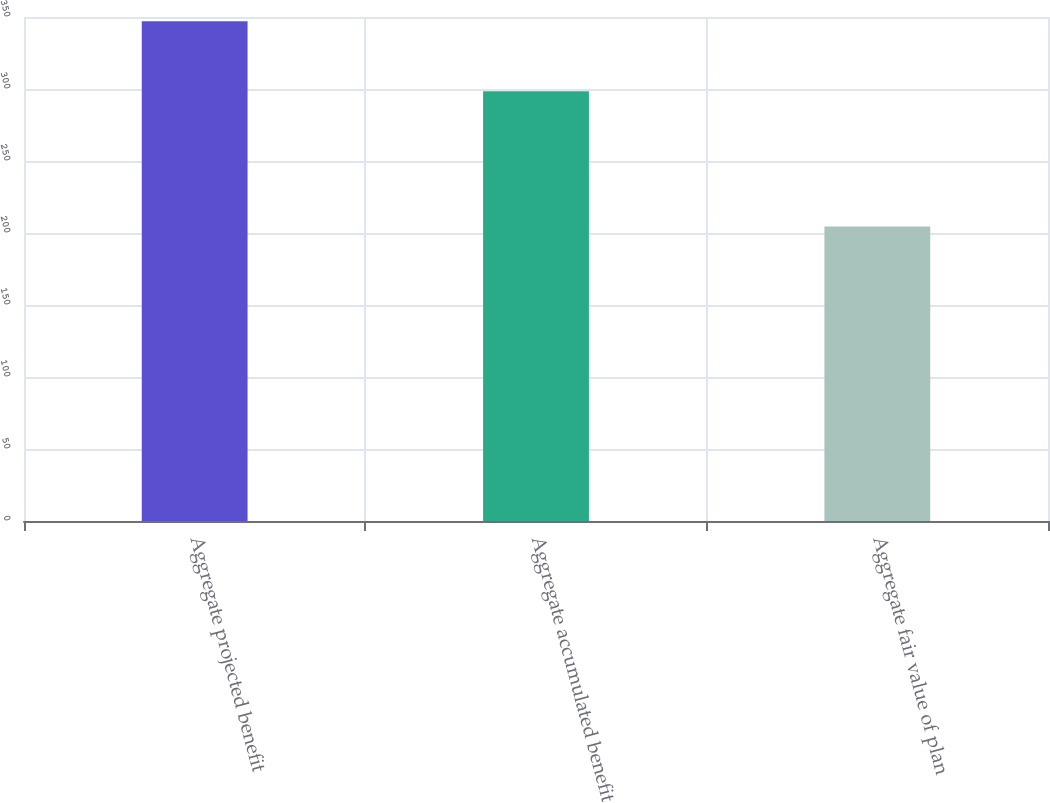Convert chart to OTSL. <chart><loc_0><loc_0><loc_500><loc_500><bar_chart><fcel>Aggregate projected benefit<fcel>Aggregate accumulated benefit<fcel>Aggregate fair value of plan<nl><fcel>347.1<fcel>298.5<fcel>204.6<nl></chart> 